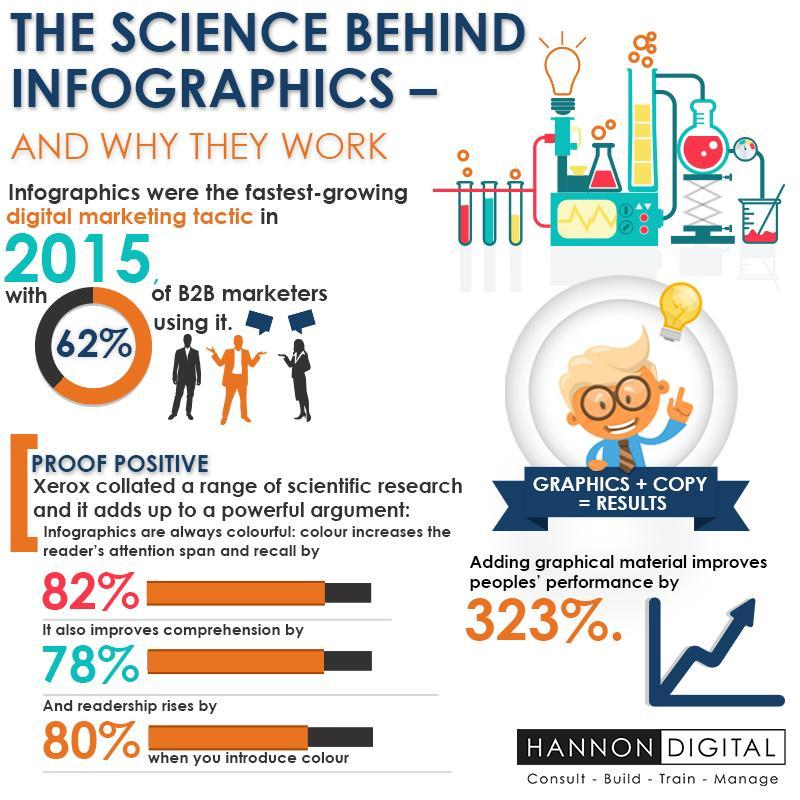What percentage of B2B marketer do not user digital marketing?
Answer the question with a short phrase. 38% What is the percentage by which colorful infographics can engage audience,  323%, 78%, 82%, or 80% 82% 